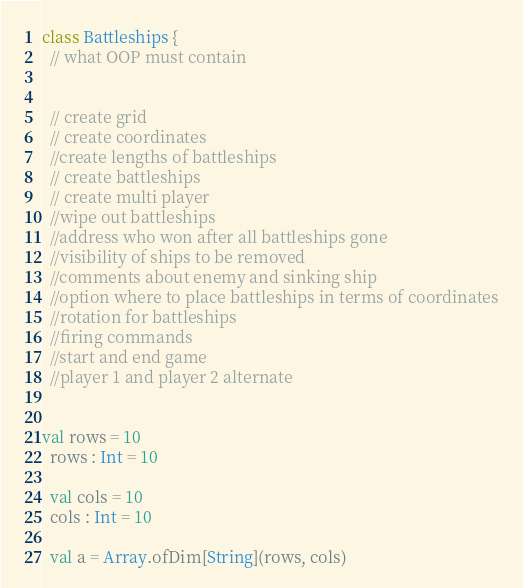Convert code to text. <code><loc_0><loc_0><loc_500><loc_500><_Scala_>class Battleships {
  // what OOP must contain


  // create grid
  // create coordinates
  //create lengths of battleships
  // create battleships
  // create multi player
  //wipe out battleships
  //address who won after all battleships gone
  //visibility of ships to be removed
  //comments about enemy and sinking ship
  //option where to place battleships in terms of coordinates
  //rotation for battleships
  //firing commands
  //start and end game
  //player 1 and player 2 alternate


val rows = 10
  rows : Int = 10

  val cols = 10
  cols : Int = 10

  val a = Array.ofDim[String](rows, cols)</code> 